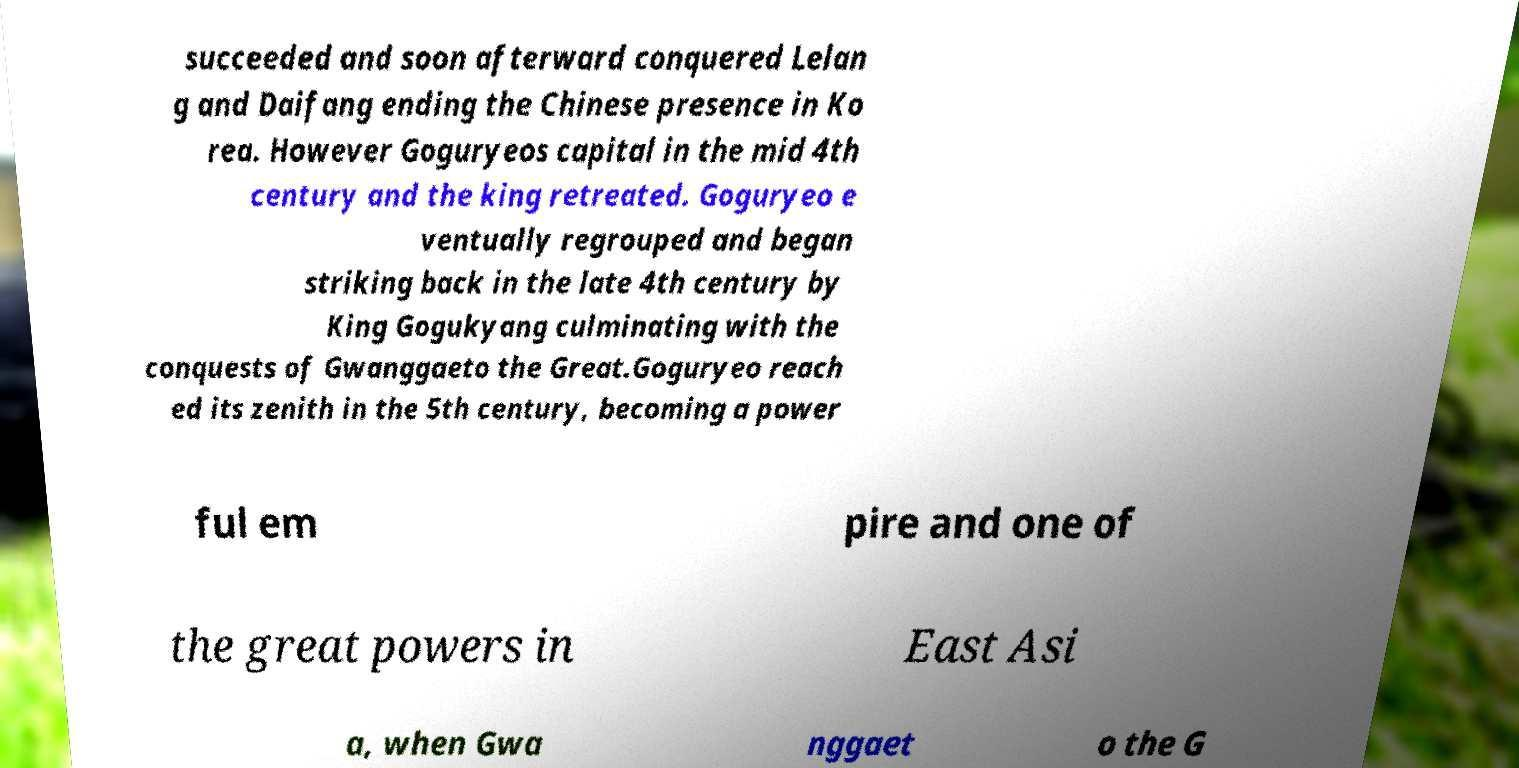What messages or text are displayed in this image? I need them in a readable, typed format. succeeded and soon afterward conquered Lelan g and Daifang ending the Chinese presence in Ko rea. However Goguryeos capital in the mid 4th century and the king retreated. Goguryeo e ventually regrouped and began striking back in the late 4th century by King Gogukyang culminating with the conquests of Gwanggaeto the Great.Goguryeo reach ed its zenith in the 5th century, becoming a power ful em pire and one of the great powers in East Asi a, when Gwa nggaet o the G 